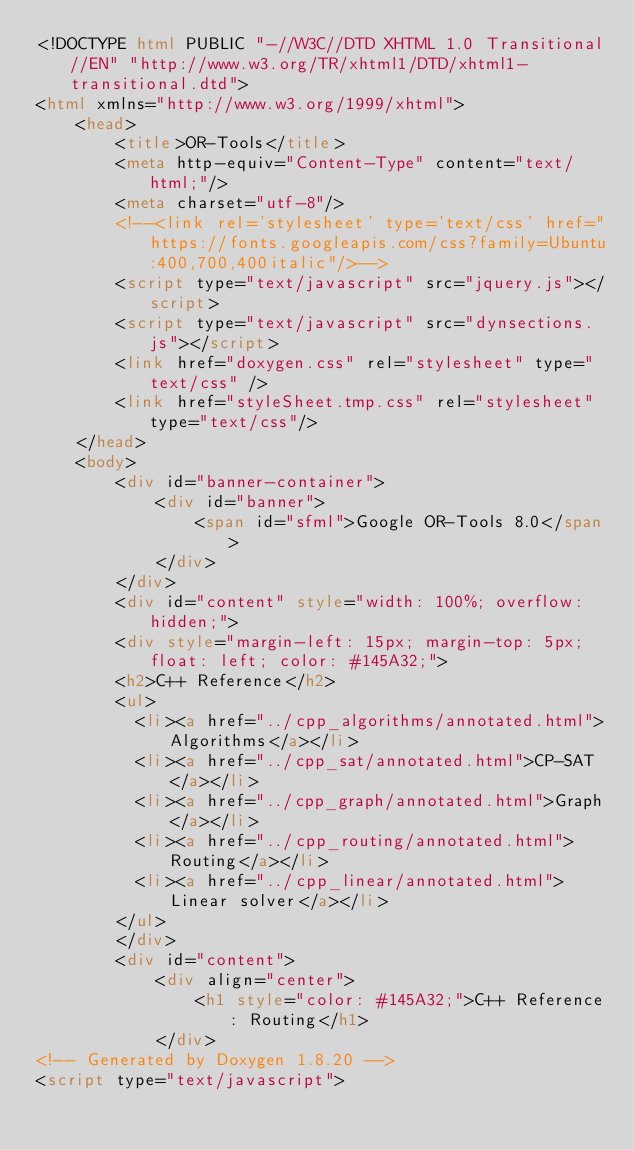<code> <loc_0><loc_0><loc_500><loc_500><_HTML_><!DOCTYPE html PUBLIC "-//W3C//DTD XHTML 1.0 Transitional//EN" "http://www.w3.org/TR/xhtml1/DTD/xhtml1-transitional.dtd">
<html xmlns="http://www.w3.org/1999/xhtml">
    <head>
        <title>OR-Tools</title>
        <meta http-equiv="Content-Type" content="text/html;"/>
        <meta charset="utf-8"/>
        <!--<link rel='stylesheet' type='text/css' href="https://fonts.googleapis.com/css?family=Ubuntu:400,700,400italic"/>-->
        <script type="text/javascript" src="jquery.js"></script>
        <script type="text/javascript" src="dynsections.js"></script>
        <link href="doxygen.css" rel="stylesheet" type="text/css" />
        <link href="styleSheet.tmp.css" rel="stylesheet" type="text/css"/>
    </head>
    <body>
        <div id="banner-container">
            <div id="banner">
                <span id="sfml">Google OR-Tools 8.0</span>
            </div>
        </div>
        <div id="content" style="width: 100%; overflow: hidden;">
        <div style="margin-left: 15px; margin-top: 5px; float: left; color: #145A32;">
        <h2>C++ Reference</h2>
        <ul>
          <li><a href="../cpp_algorithms/annotated.html">Algorithms</a></li>
          <li><a href="../cpp_sat/annotated.html">CP-SAT</a></li>
          <li><a href="../cpp_graph/annotated.html">Graph</a></li>
          <li><a href="../cpp_routing/annotated.html">Routing</a></li>
          <li><a href="../cpp_linear/annotated.html">Linear solver</a></li>
        </ul>
        </div>
        <div id="content">
            <div align="center">
                <h1 style="color: #145A32;">C++ Reference: Routing</h1>
            </div>
<!-- Generated by Doxygen 1.8.20 -->
<script type="text/javascript"></code> 